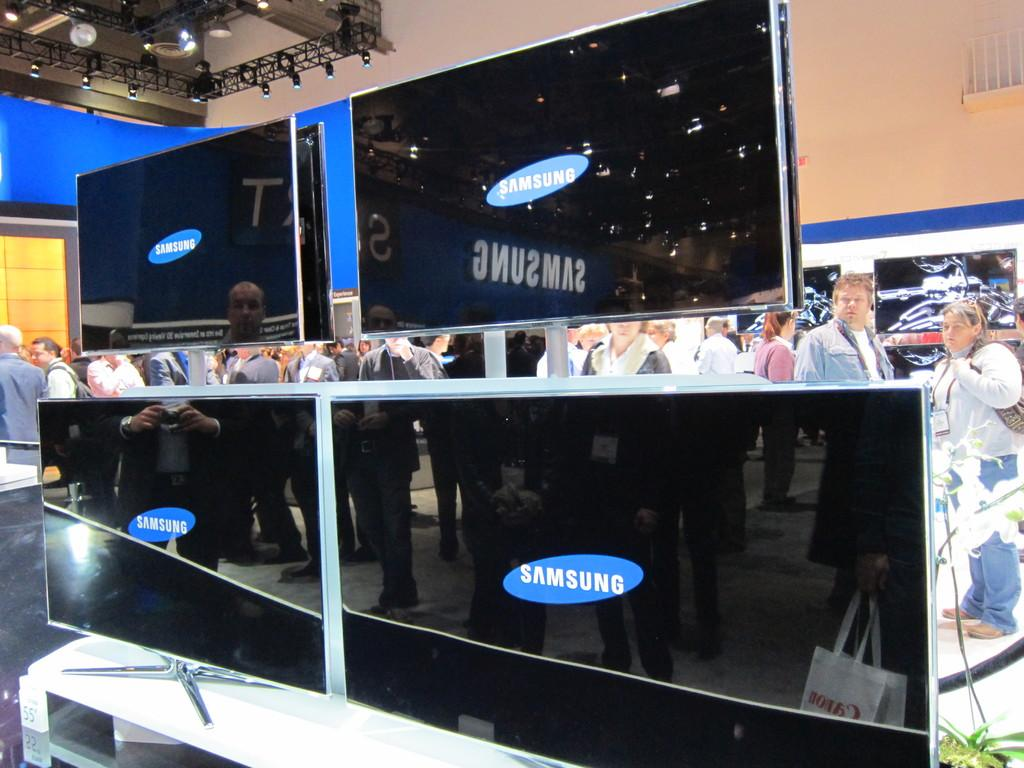<image>
Share a concise interpretation of the image provided. The new television screen on display are made by Samsung. 